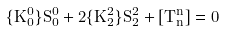Convert formula to latex. <formula><loc_0><loc_0><loc_500><loc_500>\{ K _ { 0 } ^ { 0 } \} S _ { 0 } ^ { 0 } + 2 \{ K _ { 2 } ^ { 2 } \} S _ { 2 } ^ { 2 } + [ T _ { n } ^ { n } ] = 0</formula> 